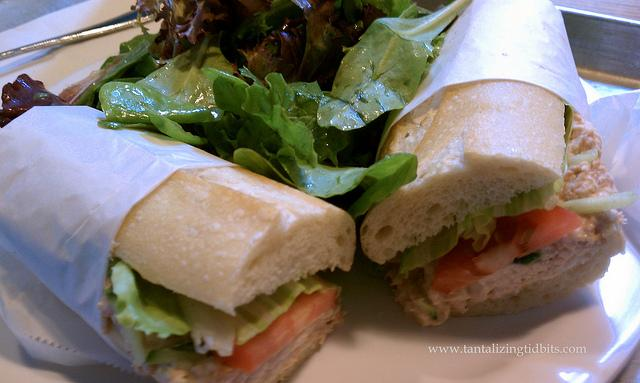What animal will most likely eat this meal? human 